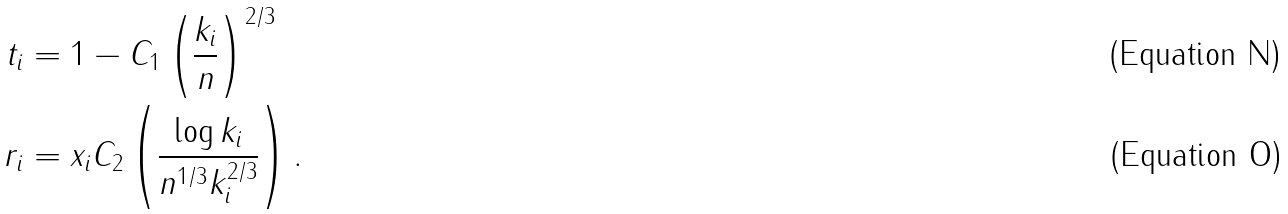Convert formula to latex. <formula><loc_0><loc_0><loc_500><loc_500>t _ { i } & = 1 - C _ { 1 } \left ( \frac { k _ { i } } { n } \right ) ^ { 2 / 3 } \\ r _ { i } & = x _ { i } C _ { 2 } \left ( \frac { \log k _ { i } } { n ^ { 1 / 3 } k _ { i } ^ { 2 / 3 } } \right ) .</formula> 